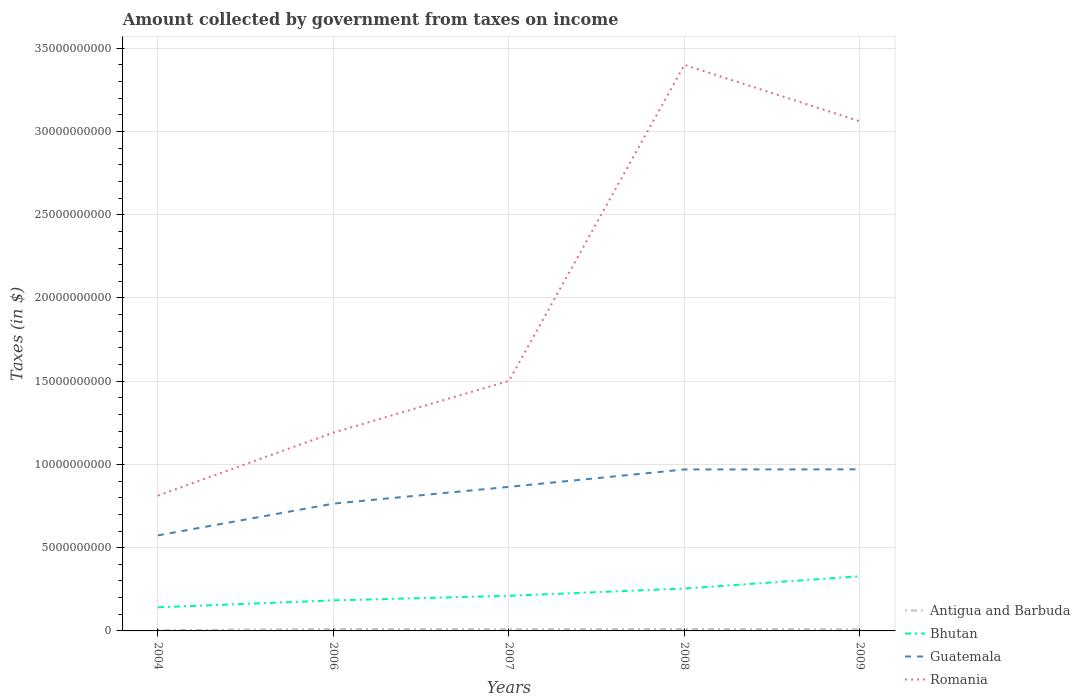How many different coloured lines are there?
Your answer should be compact. 4. Across all years, what is the maximum amount collected by government from taxes on income in Antigua and Barbuda?
Give a very brief answer. 4.64e+07. What is the total amount collected by government from taxes on income in Bhutan in the graph?
Keep it short and to the point. -4.14e+08. What is the difference between the highest and the second highest amount collected by government from taxes on income in Antigua and Barbuda?
Your answer should be very brief. 6.51e+07. Is the amount collected by government from taxes on income in Bhutan strictly greater than the amount collected by government from taxes on income in Romania over the years?
Your answer should be compact. Yes. What is the difference between two consecutive major ticks on the Y-axis?
Provide a short and direct response. 5.00e+09. Does the graph contain any zero values?
Provide a succinct answer. No. How many legend labels are there?
Give a very brief answer. 4. How are the legend labels stacked?
Your answer should be very brief. Vertical. What is the title of the graph?
Offer a very short reply. Amount collected by government from taxes on income. Does "Spain" appear as one of the legend labels in the graph?
Your answer should be compact. No. What is the label or title of the Y-axis?
Your answer should be compact. Taxes (in $). What is the Taxes (in $) of Antigua and Barbuda in 2004?
Provide a short and direct response. 4.64e+07. What is the Taxes (in $) in Bhutan in 2004?
Your response must be concise. 1.42e+09. What is the Taxes (in $) of Guatemala in 2004?
Your answer should be compact. 5.74e+09. What is the Taxes (in $) in Romania in 2004?
Make the answer very short. 8.13e+09. What is the Taxes (in $) in Antigua and Barbuda in 2006?
Offer a terse response. 1.12e+08. What is the Taxes (in $) in Bhutan in 2006?
Offer a very short reply. 1.83e+09. What is the Taxes (in $) in Guatemala in 2006?
Offer a very short reply. 7.65e+09. What is the Taxes (in $) of Romania in 2006?
Provide a succinct answer. 1.19e+1. What is the Taxes (in $) of Antigua and Barbuda in 2007?
Provide a succinct answer. 1.01e+08. What is the Taxes (in $) of Bhutan in 2007?
Your answer should be compact. 2.11e+09. What is the Taxes (in $) of Guatemala in 2007?
Provide a succinct answer. 8.65e+09. What is the Taxes (in $) in Romania in 2007?
Offer a very short reply. 1.50e+1. What is the Taxes (in $) in Antigua and Barbuda in 2008?
Your answer should be compact. 1.12e+08. What is the Taxes (in $) in Bhutan in 2008?
Keep it short and to the point. 2.55e+09. What is the Taxes (in $) in Guatemala in 2008?
Give a very brief answer. 9.70e+09. What is the Taxes (in $) in Romania in 2008?
Keep it short and to the point. 3.40e+1. What is the Taxes (in $) in Antigua and Barbuda in 2009?
Ensure brevity in your answer.  9.80e+07. What is the Taxes (in $) of Bhutan in 2009?
Your response must be concise. 3.28e+09. What is the Taxes (in $) in Guatemala in 2009?
Your answer should be very brief. 9.71e+09. What is the Taxes (in $) of Romania in 2009?
Make the answer very short. 3.06e+1. Across all years, what is the maximum Taxes (in $) in Antigua and Barbuda?
Ensure brevity in your answer.  1.12e+08. Across all years, what is the maximum Taxes (in $) of Bhutan?
Provide a succinct answer. 3.28e+09. Across all years, what is the maximum Taxes (in $) in Guatemala?
Provide a short and direct response. 9.71e+09. Across all years, what is the maximum Taxes (in $) in Romania?
Ensure brevity in your answer.  3.40e+1. Across all years, what is the minimum Taxes (in $) of Antigua and Barbuda?
Offer a terse response. 4.64e+07. Across all years, what is the minimum Taxes (in $) in Bhutan?
Ensure brevity in your answer.  1.42e+09. Across all years, what is the minimum Taxes (in $) in Guatemala?
Your answer should be very brief. 5.74e+09. Across all years, what is the minimum Taxes (in $) of Romania?
Your response must be concise. 8.13e+09. What is the total Taxes (in $) in Antigua and Barbuda in the graph?
Provide a short and direct response. 4.68e+08. What is the total Taxes (in $) in Bhutan in the graph?
Provide a short and direct response. 1.12e+1. What is the total Taxes (in $) in Guatemala in the graph?
Provide a short and direct response. 4.14e+1. What is the total Taxes (in $) of Romania in the graph?
Give a very brief answer. 9.97e+1. What is the difference between the Taxes (in $) of Antigua and Barbuda in 2004 and that in 2006?
Offer a terse response. -6.51e+07. What is the difference between the Taxes (in $) of Bhutan in 2004 and that in 2006?
Give a very brief answer. -4.14e+08. What is the difference between the Taxes (in $) of Guatemala in 2004 and that in 2006?
Offer a terse response. -1.91e+09. What is the difference between the Taxes (in $) in Romania in 2004 and that in 2006?
Your answer should be very brief. -3.78e+09. What is the difference between the Taxes (in $) in Antigua and Barbuda in 2004 and that in 2007?
Your response must be concise. -5.45e+07. What is the difference between the Taxes (in $) in Bhutan in 2004 and that in 2007?
Keep it short and to the point. -6.90e+08. What is the difference between the Taxes (in $) in Guatemala in 2004 and that in 2007?
Provide a short and direct response. -2.91e+09. What is the difference between the Taxes (in $) of Romania in 2004 and that in 2007?
Provide a short and direct response. -6.89e+09. What is the difference between the Taxes (in $) of Antigua and Barbuda in 2004 and that in 2008?
Provide a succinct answer. -6.51e+07. What is the difference between the Taxes (in $) of Bhutan in 2004 and that in 2008?
Ensure brevity in your answer.  -1.13e+09. What is the difference between the Taxes (in $) of Guatemala in 2004 and that in 2008?
Give a very brief answer. -3.96e+09. What is the difference between the Taxes (in $) in Romania in 2004 and that in 2008?
Keep it short and to the point. -2.59e+1. What is the difference between the Taxes (in $) in Antigua and Barbuda in 2004 and that in 2009?
Ensure brevity in your answer.  -5.16e+07. What is the difference between the Taxes (in $) of Bhutan in 2004 and that in 2009?
Your answer should be compact. -1.86e+09. What is the difference between the Taxes (in $) of Guatemala in 2004 and that in 2009?
Give a very brief answer. -3.97e+09. What is the difference between the Taxes (in $) of Romania in 2004 and that in 2009?
Your answer should be very brief. -2.25e+1. What is the difference between the Taxes (in $) in Antigua and Barbuda in 2006 and that in 2007?
Offer a very short reply. 1.06e+07. What is the difference between the Taxes (in $) of Bhutan in 2006 and that in 2007?
Offer a very short reply. -2.76e+08. What is the difference between the Taxes (in $) in Guatemala in 2006 and that in 2007?
Provide a succinct answer. -1.01e+09. What is the difference between the Taxes (in $) of Romania in 2006 and that in 2007?
Your answer should be very brief. -3.11e+09. What is the difference between the Taxes (in $) of Antigua and Barbuda in 2006 and that in 2008?
Offer a very short reply. 0. What is the difference between the Taxes (in $) in Bhutan in 2006 and that in 2008?
Your response must be concise. -7.14e+08. What is the difference between the Taxes (in $) in Guatemala in 2006 and that in 2008?
Give a very brief answer. -2.05e+09. What is the difference between the Taxes (in $) in Romania in 2006 and that in 2008?
Ensure brevity in your answer.  -2.21e+1. What is the difference between the Taxes (in $) in Antigua and Barbuda in 2006 and that in 2009?
Offer a very short reply. 1.35e+07. What is the difference between the Taxes (in $) in Bhutan in 2006 and that in 2009?
Your answer should be compact. -1.45e+09. What is the difference between the Taxes (in $) in Guatemala in 2006 and that in 2009?
Your response must be concise. -2.06e+09. What is the difference between the Taxes (in $) in Romania in 2006 and that in 2009?
Your answer should be very brief. -1.87e+1. What is the difference between the Taxes (in $) of Antigua and Barbuda in 2007 and that in 2008?
Your answer should be compact. -1.06e+07. What is the difference between the Taxes (in $) in Bhutan in 2007 and that in 2008?
Your answer should be very brief. -4.38e+08. What is the difference between the Taxes (in $) in Guatemala in 2007 and that in 2008?
Make the answer very short. -1.04e+09. What is the difference between the Taxes (in $) of Romania in 2007 and that in 2008?
Make the answer very short. -1.90e+1. What is the difference between the Taxes (in $) of Antigua and Barbuda in 2007 and that in 2009?
Give a very brief answer. 2.90e+06. What is the difference between the Taxes (in $) in Bhutan in 2007 and that in 2009?
Provide a short and direct response. -1.17e+09. What is the difference between the Taxes (in $) in Guatemala in 2007 and that in 2009?
Ensure brevity in your answer.  -1.05e+09. What is the difference between the Taxes (in $) in Romania in 2007 and that in 2009?
Ensure brevity in your answer.  -1.56e+1. What is the difference between the Taxes (in $) in Antigua and Barbuda in 2008 and that in 2009?
Provide a succinct answer. 1.35e+07. What is the difference between the Taxes (in $) of Bhutan in 2008 and that in 2009?
Offer a very short reply. -7.35e+08. What is the difference between the Taxes (in $) of Guatemala in 2008 and that in 2009?
Give a very brief answer. -7.40e+06. What is the difference between the Taxes (in $) of Romania in 2008 and that in 2009?
Keep it short and to the point. 3.39e+09. What is the difference between the Taxes (in $) of Antigua and Barbuda in 2004 and the Taxes (in $) of Bhutan in 2006?
Offer a very short reply. -1.79e+09. What is the difference between the Taxes (in $) of Antigua and Barbuda in 2004 and the Taxes (in $) of Guatemala in 2006?
Give a very brief answer. -7.60e+09. What is the difference between the Taxes (in $) in Antigua and Barbuda in 2004 and the Taxes (in $) in Romania in 2006?
Your answer should be compact. -1.19e+1. What is the difference between the Taxes (in $) of Bhutan in 2004 and the Taxes (in $) of Guatemala in 2006?
Give a very brief answer. -6.23e+09. What is the difference between the Taxes (in $) of Bhutan in 2004 and the Taxes (in $) of Romania in 2006?
Your answer should be very brief. -1.05e+1. What is the difference between the Taxes (in $) in Guatemala in 2004 and the Taxes (in $) in Romania in 2006?
Your answer should be compact. -6.17e+09. What is the difference between the Taxes (in $) in Antigua and Barbuda in 2004 and the Taxes (in $) in Bhutan in 2007?
Give a very brief answer. -2.06e+09. What is the difference between the Taxes (in $) of Antigua and Barbuda in 2004 and the Taxes (in $) of Guatemala in 2007?
Your response must be concise. -8.61e+09. What is the difference between the Taxes (in $) in Antigua and Barbuda in 2004 and the Taxes (in $) in Romania in 2007?
Provide a short and direct response. -1.50e+1. What is the difference between the Taxes (in $) of Bhutan in 2004 and the Taxes (in $) of Guatemala in 2007?
Make the answer very short. -7.23e+09. What is the difference between the Taxes (in $) of Bhutan in 2004 and the Taxes (in $) of Romania in 2007?
Provide a succinct answer. -1.36e+1. What is the difference between the Taxes (in $) in Guatemala in 2004 and the Taxes (in $) in Romania in 2007?
Ensure brevity in your answer.  -9.28e+09. What is the difference between the Taxes (in $) in Antigua and Barbuda in 2004 and the Taxes (in $) in Bhutan in 2008?
Give a very brief answer. -2.50e+09. What is the difference between the Taxes (in $) of Antigua and Barbuda in 2004 and the Taxes (in $) of Guatemala in 2008?
Offer a very short reply. -9.65e+09. What is the difference between the Taxes (in $) in Antigua and Barbuda in 2004 and the Taxes (in $) in Romania in 2008?
Your answer should be compact. -3.40e+1. What is the difference between the Taxes (in $) of Bhutan in 2004 and the Taxes (in $) of Guatemala in 2008?
Keep it short and to the point. -8.28e+09. What is the difference between the Taxes (in $) of Bhutan in 2004 and the Taxes (in $) of Romania in 2008?
Give a very brief answer. -3.26e+1. What is the difference between the Taxes (in $) of Guatemala in 2004 and the Taxes (in $) of Romania in 2008?
Provide a succinct answer. -2.83e+1. What is the difference between the Taxes (in $) of Antigua and Barbuda in 2004 and the Taxes (in $) of Bhutan in 2009?
Provide a short and direct response. -3.24e+09. What is the difference between the Taxes (in $) of Antigua and Barbuda in 2004 and the Taxes (in $) of Guatemala in 2009?
Your answer should be compact. -9.66e+09. What is the difference between the Taxes (in $) in Antigua and Barbuda in 2004 and the Taxes (in $) in Romania in 2009?
Your response must be concise. -3.06e+1. What is the difference between the Taxes (in $) in Bhutan in 2004 and the Taxes (in $) in Guatemala in 2009?
Offer a very short reply. -8.29e+09. What is the difference between the Taxes (in $) of Bhutan in 2004 and the Taxes (in $) of Romania in 2009?
Provide a succinct answer. -2.92e+1. What is the difference between the Taxes (in $) of Guatemala in 2004 and the Taxes (in $) of Romania in 2009?
Provide a short and direct response. -2.49e+1. What is the difference between the Taxes (in $) in Antigua and Barbuda in 2006 and the Taxes (in $) in Bhutan in 2007?
Your answer should be very brief. -2.00e+09. What is the difference between the Taxes (in $) in Antigua and Barbuda in 2006 and the Taxes (in $) in Guatemala in 2007?
Your answer should be very brief. -8.54e+09. What is the difference between the Taxes (in $) in Antigua and Barbuda in 2006 and the Taxes (in $) in Romania in 2007?
Give a very brief answer. -1.49e+1. What is the difference between the Taxes (in $) of Bhutan in 2006 and the Taxes (in $) of Guatemala in 2007?
Your answer should be compact. -6.82e+09. What is the difference between the Taxes (in $) of Bhutan in 2006 and the Taxes (in $) of Romania in 2007?
Give a very brief answer. -1.32e+1. What is the difference between the Taxes (in $) of Guatemala in 2006 and the Taxes (in $) of Romania in 2007?
Ensure brevity in your answer.  -7.37e+09. What is the difference between the Taxes (in $) in Antigua and Barbuda in 2006 and the Taxes (in $) in Bhutan in 2008?
Ensure brevity in your answer.  -2.44e+09. What is the difference between the Taxes (in $) in Antigua and Barbuda in 2006 and the Taxes (in $) in Guatemala in 2008?
Offer a terse response. -9.59e+09. What is the difference between the Taxes (in $) in Antigua and Barbuda in 2006 and the Taxes (in $) in Romania in 2008?
Your response must be concise. -3.39e+1. What is the difference between the Taxes (in $) of Bhutan in 2006 and the Taxes (in $) of Guatemala in 2008?
Keep it short and to the point. -7.87e+09. What is the difference between the Taxes (in $) in Bhutan in 2006 and the Taxes (in $) in Romania in 2008?
Give a very brief answer. -3.22e+1. What is the difference between the Taxes (in $) of Guatemala in 2006 and the Taxes (in $) of Romania in 2008?
Give a very brief answer. -2.64e+1. What is the difference between the Taxes (in $) of Antigua and Barbuda in 2006 and the Taxes (in $) of Bhutan in 2009?
Provide a succinct answer. -3.17e+09. What is the difference between the Taxes (in $) of Antigua and Barbuda in 2006 and the Taxes (in $) of Guatemala in 2009?
Ensure brevity in your answer.  -9.59e+09. What is the difference between the Taxes (in $) of Antigua and Barbuda in 2006 and the Taxes (in $) of Romania in 2009?
Make the answer very short. -3.05e+1. What is the difference between the Taxes (in $) of Bhutan in 2006 and the Taxes (in $) of Guatemala in 2009?
Offer a terse response. -7.87e+09. What is the difference between the Taxes (in $) of Bhutan in 2006 and the Taxes (in $) of Romania in 2009?
Make the answer very short. -2.88e+1. What is the difference between the Taxes (in $) of Guatemala in 2006 and the Taxes (in $) of Romania in 2009?
Ensure brevity in your answer.  -2.30e+1. What is the difference between the Taxes (in $) in Antigua and Barbuda in 2007 and the Taxes (in $) in Bhutan in 2008?
Provide a succinct answer. -2.45e+09. What is the difference between the Taxes (in $) in Antigua and Barbuda in 2007 and the Taxes (in $) in Guatemala in 2008?
Your response must be concise. -9.60e+09. What is the difference between the Taxes (in $) in Antigua and Barbuda in 2007 and the Taxes (in $) in Romania in 2008?
Provide a short and direct response. -3.39e+1. What is the difference between the Taxes (in $) of Bhutan in 2007 and the Taxes (in $) of Guatemala in 2008?
Offer a very short reply. -7.59e+09. What is the difference between the Taxes (in $) in Bhutan in 2007 and the Taxes (in $) in Romania in 2008?
Offer a very short reply. -3.19e+1. What is the difference between the Taxes (in $) of Guatemala in 2007 and the Taxes (in $) of Romania in 2008?
Your response must be concise. -2.53e+1. What is the difference between the Taxes (in $) in Antigua and Barbuda in 2007 and the Taxes (in $) in Bhutan in 2009?
Your answer should be very brief. -3.18e+09. What is the difference between the Taxes (in $) in Antigua and Barbuda in 2007 and the Taxes (in $) in Guatemala in 2009?
Give a very brief answer. -9.60e+09. What is the difference between the Taxes (in $) of Antigua and Barbuda in 2007 and the Taxes (in $) of Romania in 2009?
Make the answer very short. -3.05e+1. What is the difference between the Taxes (in $) in Bhutan in 2007 and the Taxes (in $) in Guatemala in 2009?
Ensure brevity in your answer.  -7.60e+09. What is the difference between the Taxes (in $) in Bhutan in 2007 and the Taxes (in $) in Romania in 2009?
Offer a very short reply. -2.85e+1. What is the difference between the Taxes (in $) in Guatemala in 2007 and the Taxes (in $) in Romania in 2009?
Ensure brevity in your answer.  -2.20e+1. What is the difference between the Taxes (in $) in Antigua and Barbuda in 2008 and the Taxes (in $) in Bhutan in 2009?
Your answer should be compact. -3.17e+09. What is the difference between the Taxes (in $) of Antigua and Barbuda in 2008 and the Taxes (in $) of Guatemala in 2009?
Ensure brevity in your answer.  -9.59e+09. What is the difference between the Taxes (in $) of Antigua and Barbuda in 2008 and the Taxes (in $) of Romania in 2009?
Your response must be concise. -3.05e+1. What is the difference between the Taxes (in $) in Bhutan in 2008 and the Taxes (in $) in Guatemala in 2009?
Make the answer very short. -7.16e+09. What is the difference between the Taxes (in $) of Bhutan in 2008 and the Taxes (in $) of Romania in 2009?
Give a very brief answer. -2.81e+1. What is the difference between the Taxes (in $) in Guatemala in 2008 and the Taxes (in $) in Romania in 2009?
Offer a very short reply. -2.09e+1. What is the average Taxes (in $) of Antigua and Barbuda per year?
Offer a terse response. 9.37e+07. What is the average Taxes (in $) of Bhutan per year?
Offer a terse response. 2.24e+09. What is the average Taxes (in $) of Guatemala per year?
Ensure brevity in your answer.  8.29e+09. What is the average Taxes (in $) in Romania per year?
Keep it short and to the point. 1.99e+1. In the year 2004, what is the difference between the Taxes (in $) of Antigua and Barbuda and Taxes (in $) of Bhutan?
Make the answer very short. -1.37e+09. In the year 2004, what is the difference between the Taxes (in $) in Antigua and Barbuda and Taxes (in $) in Guatemala?
Your answer should be very brief. -5.69e+09. In the year 2004, what is the difference between the Taxes (in $) of Antigua and Barbuda and Taxes (in $) of Romania?
Offer a terse response. -8.08e+09. In the year 2004, what is the difference between the Taxes (in $) in Bhutan and Taxes (in $) in Guatemala?
Give a very brief answer. -4.32e+09. In the year 2004, what is the difference between the Taxes (in $) of Bhutan and Taxes (in $) of Romania?
Your response must be concise. -6.71e+09. In the year 2004, what is the difference between the Taxes (in $) of Guatemala and Taxes (in $) of Romania?
Your answer should be compact. -2.39e+09. In the year 2006, what is the difference between the Taxes (in $) in Antigua and Barbuda and Taxes (in $) in Bhutan?
Provide a succinct answer. -1.72e+09. In the year 2006, what is the difference between the Taxes (in $) of Antigua and Barbuda and Taxes (in $) of Guatemala?
Give a very brief answer. -7.54e+09. In the year 2006, what is the difference between the Taxes (in $) in Antigua and Barbuda and Taxes (in $) in Romania?
Keep it short and to the point. -1.18e+1. In the year 2006, what is the difference between the Taxes (in $) in Bhutan and Taxes (in $) in Guatemala?
Offer a very short reply. -5.81e+09. In the year 2006, what is the difference between the Taxes (in $) in Bhutan and Taxes (in $) in Romania?
Give a very brief answer. -1.01e+1. In the year 2006, what is the difference between the Taxes (in $) in Guatemala and Taxes (in $) in Romania?
Offer a very short reply. -4.27e+09. In the year 2007, what is the difference between the Taxes (in $) of Antigua and Barbuda and Taxes (in $) of Bhutan?
Provide a succinct answer. -2.01e+09. In the year 2007, what is the difference between the Taxes (in $) of Antigua and Barbuda and Taxes (in $) of Guatemala?
Keep it short and to the point. -8.55e+09. In the year 2007, what is the difference between the Taxes (in $) in Antigua and Barbuda and Taxes (in $) in Romania?
Your response must be concise. -1.49e+1. In the year 2007, what is the difference between the Taxes (in $) of Bhutan and Taxes (in $) of Guatemala?
Ensure brevity in your answer.  -6.54e+09. In the year 2007, what is the difference between the Taxes (in $) in Bhutan and Taxes (in $) in Romania?
Your answer should be compact. -1.29e+1. In the year 2007, what is the difference between the Taxes (in $) of Guatemala and Taxes (in $) of Romania?
Provide a succinct answer. -6.37e+09. In the year 2008, what is the difference between the Taxes (in $) of Antigua and Barbuda and Taxes (in $) of Bhutan?
Offer a terse response. -2.44e+09. In the year 2008, what is the difference between the Taxes (in $) of Antigua and Barbuda and Taxes (in $) of Guatemala?
Offer a terse response. -9.59e+09. In the year 2008, what is the difference between the Taxes (in $) of Antigua and Barbuda and Taxes (in $) of Romania?
Provide a short and direct response. -3.39e+1. In the year 2008, what is the difference between the Taxes (in $) in Bhutan and Taxes (in $) in Guatemala?
Your answer should be compact. -7.15e+09. In the year 2008, what is the difference between the Taxes (in $) of Bhutan and Taxes (in $) of Romania?
Offer a very short reply. -3.15e+1. In the year 2008, what is the difference between the Taxes (in $) in Guatemala and Taxes (in $) in Romania?
Provide a short and direct response. -2.43e+1. In the year 2009, what is the difference between the Taxes (in $) of Antigua and Barbuda and Taxes (in $) of Bhutan?
Provide a succinct answer. -3.18e+09. In the year 2009, what is the difference between the Taxes (in $) in Antigua and Barbuda and Taxes (in $) in Guatemala?
Provide a succinct answer. -9.61e+09. In the year 2009, what is the difference between the Taxes (in $) in Antigua and Barbuda and Taxes (in $) in Romania?
Provide a short and direct response. -3.05e+1. In the year 2009, what is the difference between the Taxes (in $) in Bhutan and Taxes (in $) in Guatemala?
Make the answer very short. -6.42e+09. In the year 2009, what is the difference between the Taxes (in $) of Bhutan and Taxes (in $) of Romania?
Your response must be concise. -2.73e+1. In the year 2009, what is the difference between the Taxes (in $) of Guatemala and Taxes (in $) of Romania?
Offer a very short reply. -2.09e+1. What is the ratio of the Taxes (in $) in Antigua and Barbuda in 2004 to that in 2006?
Give a very brief answer. 0.42. What is the ratio of the Taxes (in $) in Bhutan in 2004 to that in 2006?
Give a very brief answer. 0.77. What is the ratio of the Taxes (in $) of Guatemala in 2004 to that in 2006?
Your answer should be compact. 0.75. What is the ratio of the Taxes (in $) in Romania in 2004 to that in 2006?
Your answer should be very brief. 0.68. What is the ratio of the Taxes (in $) of Antigua and Barbuda in 2004 to that in 2007?
Keep it short and to the point. 0.46. What is the ratio of the Taxes (in $) in Bhutan in 2004 to that in 2007?
Make the answer very short. 0.67. What is the ratio of the Taxes (in $) in Guatemala in 2004 to that in 2007?
Provide a short and direct response. 0.66. What is the ratio of the Taxes (in $) of Romania in 2004 to that in 2007?
Provide a succinct answer. 0.54. What is the ratio of the Taxes (in $) in Antigua and Barbuda in 2004 to that in 2008?
Offer a terse response. 0.42. What is the ratio of the Taxes (in $) in Bhutan in 2004 to that in 2008?
Give a very brief answer. 0.56. What is the ratio of the Taxes (in $) in Guatemala in 2004 to that in 2008?
Your answer should be compact. 0.59. What is the ratio of the Taxes (in $) of Romania in 2004 to that in 2008?
Keep it short and to the point. 0.24. What is the ratio of the Taxes (in $) in Antigua and Barbuda in 2004 to that in 2009?
Offer a terse response. 0.47. What is the ratio of the Taxes (in $) of Bhutan in 2004 to that in 2009?
Ensure brevity in your answer.  0.43. What is the ratio of the Taxes (in $) in Guatemala in 2004 to that in 2009?
Offer a very short reply. 0.59. What is the ratio of the Taxes (in $) in Romania in 2004 to that in 2009?
Make the answer very short. 0.27. What is the ratio of the Taxes (in $) of Antigua and Barbuda in 2006 to that in 2007?
Provide a succinct answer. 1.11. What is the ratio of the Taxes (in $) in Bhutan in 2006 to that in 2007?
Provide a short and direct response. 0.87. What is the ratio of the Taxes (in $) in Guatemala in 2006 to that in 2007?
Make the answer very short. 0.88. What is the ratio of the Taxes (in $) of Romania in 2006 to that in 2007?
Your answer should be compact. 0.79. What is the ratio of the Taxes (in $) in Antigua and Barbuda in 2006 to that in 2008?
Give a very brief answer. 1. What is the ratio of the Taxes (in $) of Bhutan in 2006 to that in 2008?
Offer a terse response. 0.72. What is the ratio of the Taxes (in $) of Guatemala in 2006 to that in 2008?
Your response must be concise. 0.79. What is the ratio of the Taxes (in $) of Romania in 2006 to that in 2008?
Your answer should be very brief. 0.35. What is the ratio of the Taxes (in $) of Antigua and Barbuda in 2006 to that in 2009?
Provide a short and direct response. 1.14. What is the ratio of the Taxes (in $) in Bhutan in 2006 to that in 2009?
Give a very brief answer. 0.56. What is the ratio of the Taxes (in $) in Guatemala in 2006 to that in 2009?
Make the answer very short. 0.79. What is the ratio of the Taxes (in $) in Romania in 2006 to that in 2009?
Your answer should be very brief. 0.39. What is the ratio of the Taxes (in $) of Antigua and Barbuda in 2007 to that in 2008?
Your answer should be compact. 0.9. What is the ratio of the Taxes (in $) of Bhutan in 2007 to that in 2008?
Offer a terse response. 0.83. What is the ratio of the Taxes (in $) in Guatemala in 2007 to that in 2008?
Offer a very short reply. 0.89. What is the ratio of the Taxes (in $) in Romania in 2007 to that in 2008?
Give a very brief answer. 0.44. What is the ratio of the Taxes (in $) in Antigua and Barbuda in 2007 to that in 2009?
Offer a terse response. 1.03. What is the ratio of the Taxes (in $) in Bhutan in 2007 to that in 2009?
Offer a very short reply. 0.64. What is the ratio of the Taxes (in $) in Guatemala in 2007 to that in 2009?
Provide a succinct answer. 0.89. What is the ratio of the Taxes (in $) of Romania in 2007 to that in 2009?
Ensure brevity in your answer.  0.49. What is the ratio of the Taxes (in $) of Antigua and Barbuda in 2008 to that in 2009?
Your answer should be very brief. 1.14. What is the ratio of the Taxes (in $) of Bhutan in 2008 to that in 2009?
Ensure brevity in your answer.  0.78. What is the ratio of the Taxes (in $) of Romania in 2008 to that in 2009?
Your answer should be compact. 1.11. What is the difference between the highest and the second highest Taxes (in $) of Bhutan?
Make the answer very short. 7.35e+08. What is the difference between the highest and the second highest Taxes (in $) in Guatemala?
Keep it short and to the point. 7.40e+06. What is the difference between the highest and the second highest Taxes (in $) of Romania?
Make the answer very short. 3.39e+09. What is the difference between the highest and the lowest Taxes (in $) of Antigua and Barbuda?
Give a very brief answer. 6.51e+07. What is the difference between the highest and the lowest Taxes (in $) of Bhutan?
Your response must be concise. 1.86e+09. What is the difference between the highest and the lowest Taxes (in $) of Guatemala?
Make the answer very short. 3.97e+09. What is the difference between the highest and the lowest Taxes (in $) of Romania?
Make the answer very short. 2.59e+1. 